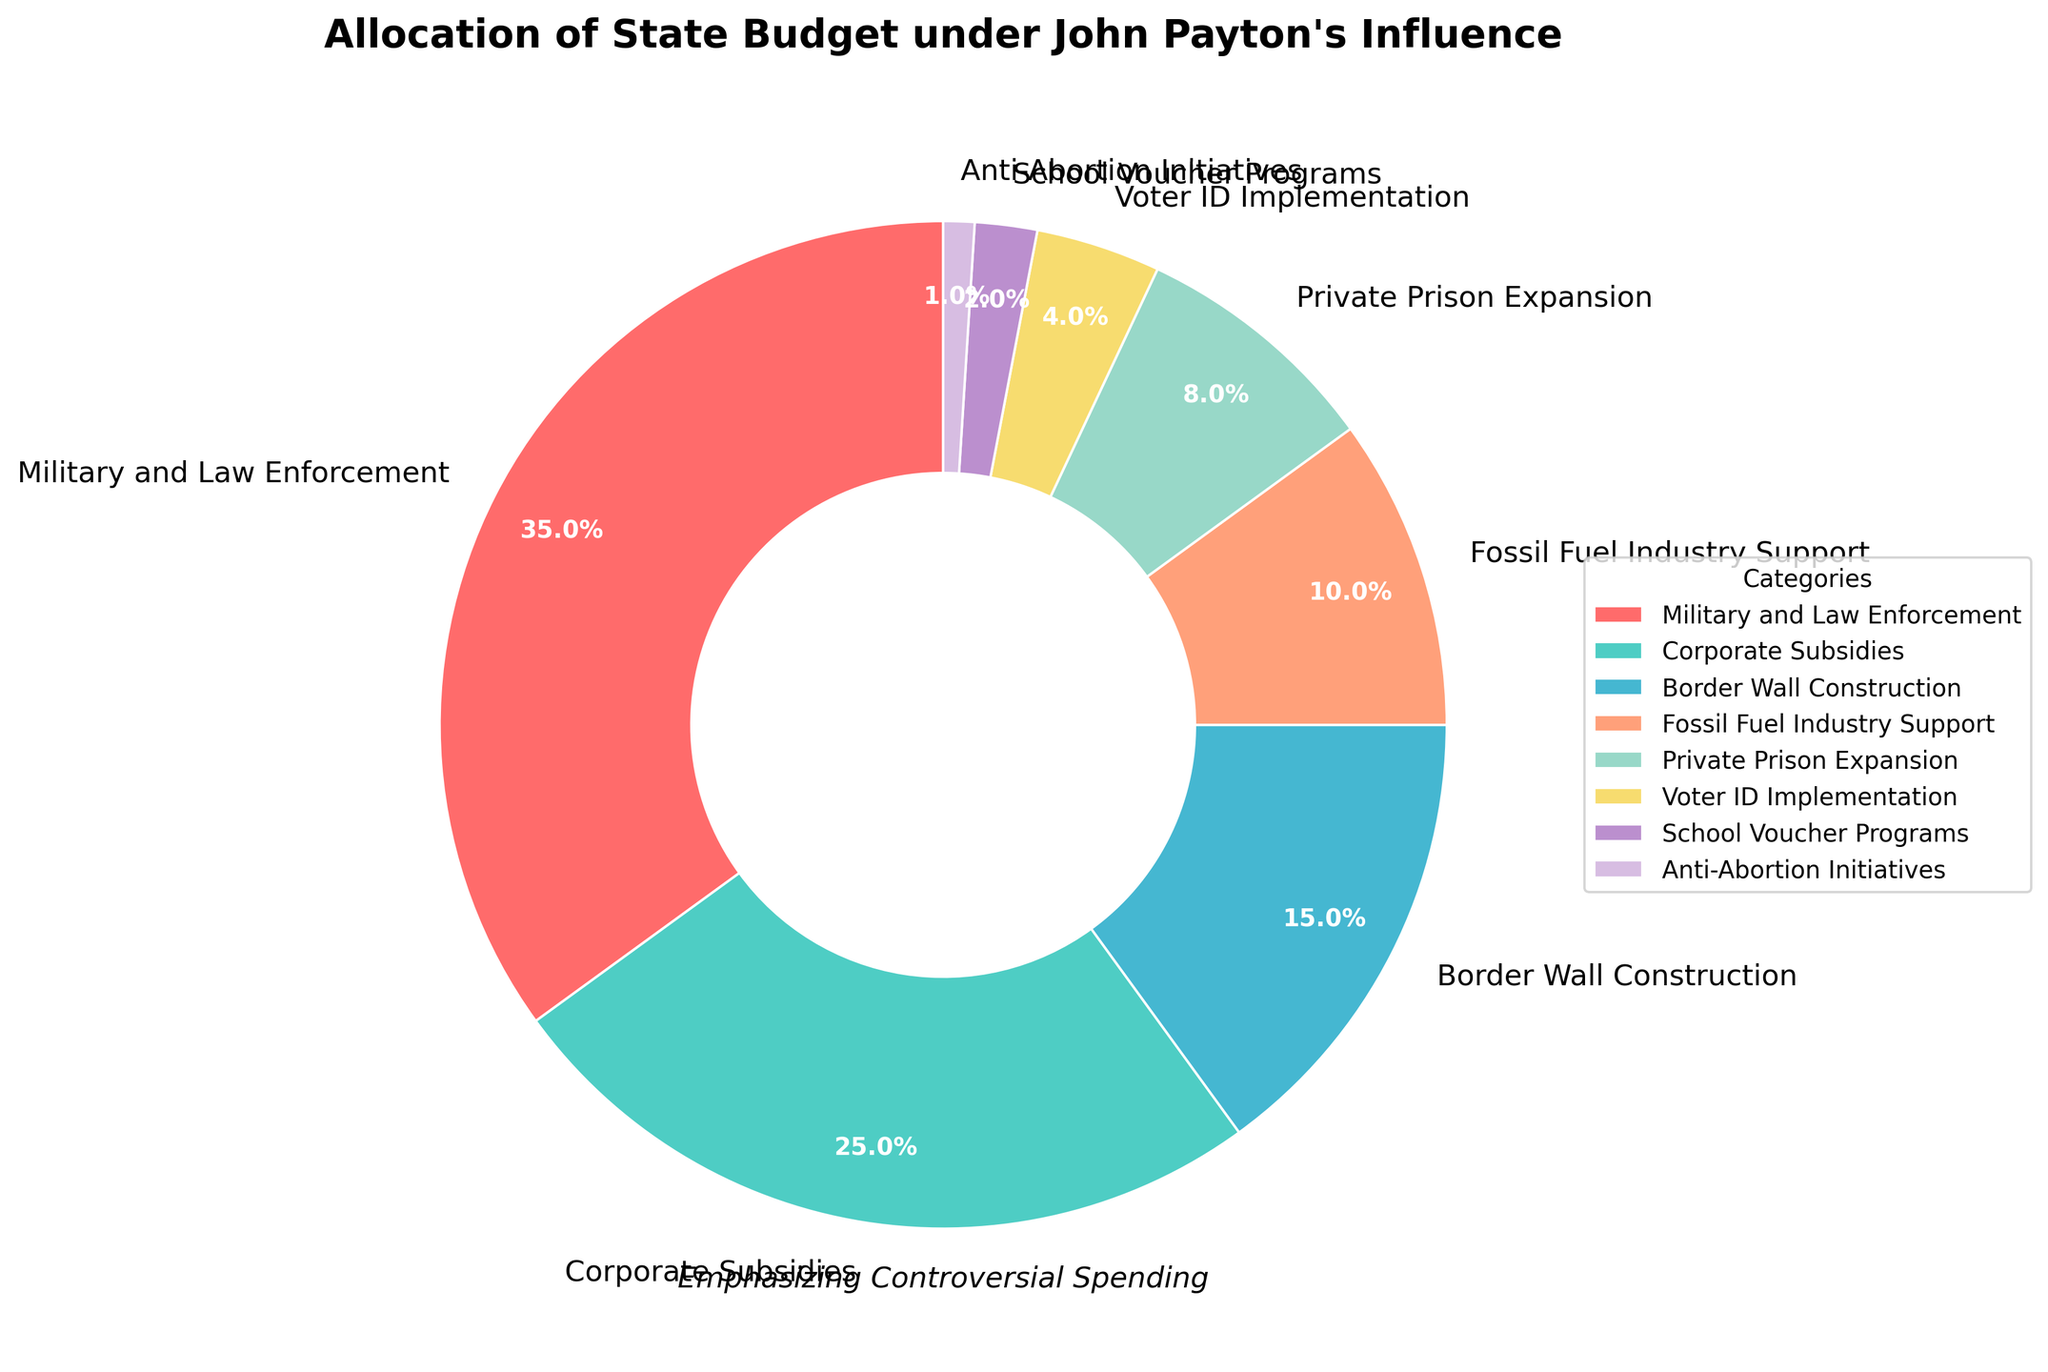What percentage of the budget is allocated to Private Prison Expansion and Voter ID Implementation combined? Private Prison Expansion is 8% and Voter ID Implementation is 4%. Summing them gives 8% + 4% = 12%.
Answer: 12% How does the percentage allocated to Corporate Subsidies compare to that allocated to Border Wall Construction? Corporate Subsidies receive 25% of the budget while Border Wall Construction receives 15% of the budget. 25% is greater than 15%.
Answer: Corporate Subsidies receive 10% more than Border Wall Construction Which category receives the least budget allocation, and what is the amount? By looking at the chart, Anti-Abortion Initiatives receive the least budget, which is 1%.
Answer: Anti-Abortion Initiatives, 1% What is the difference in budget allocation between Military and Law Enforcement and Fossil Fuel Industry Support? Military and Law Enforcement is allocated 35% and Fossil Fuel Industry Support is allocated 10%. The difference is 35% - 10% = 25%.
Answer: 25% By how much do Corporate Subsidies and Private Prison Expansion combined exceed the allocation to School Voucher Programs? Corporate Subsidies are 25% and Private Prison Expansion is 8%. Combined they are 25% + 8% = 33%. School Voucher Programs are 2%. The difference is 33% - 2% = 31%.
Answer: 31% What category is represented by the yellow section in the pie chart? The pie chart section colored yellow corresponds to Voter ID Implementation.
Answer: Voter ID Implementation If the total budget is $100 million, how much is allocated to the Fossil Fuel Industry Support? The Fossil Fuel Industry Support allocation is 10%. Therefore, 10% of $100 million is 0.1 * $100 million = $10 million.
Answer: $10 million Which two categories combined make up a third of the budget? Border Wall Construction is 15% and Fossil Fuel Industry Support is 10%. Combined they make up 15% + 10% = 25%, which is less than a third. However, Private Prison Expansion is 8%, and Voter ID Implementation is 4%.
Answer: No two categories combined make exactly a third; the closest are Private Prison Expansion (8%) and Voter ID Implementation (4%) which combined is 12% What is the median percentage value of all the categories listed? Arranging the percentages in ascending order: 1%, 2%, 4%, 8%, 10%, 15%, 25%, 35%. With 8 categories, the median is the average of the 4th and 5th values: (8% + 10%) / 2 = 9%.
Answer: 9% Which categories receive more than 20% of the budget allocation? By inspecting the chart, categories with more than 20% are Military and Law Enforcement (35%) and Corporate Subsidies (25%).
Answer: Military and Law Enforcement, Corporate Subsidies 